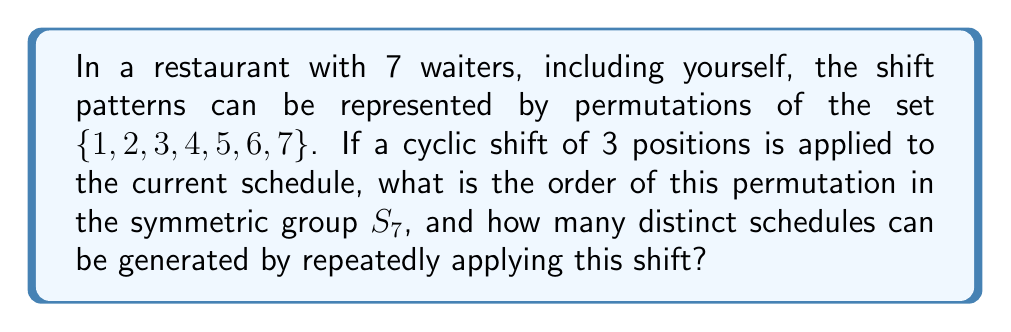What is the answer to this math problem? 1) The cyclic shift of 3 positions can be represented as the permutation:
   $\sigma = (1234567) \mapsto (4567123)$

2) This permutation can be written in cycle notation as:
   $\sigma = (1473625)$

3) The order of a permutation is the least common multiple (LCM) of the lengths of its disjoint cycles. Here, we have a single cycle of length 7.

4) Therefore, the order of $\sigma$ in $S_7$ is 7.

5) The number of distinct schedules generated by repeatedly applying this shift is equal to the order of the permutation.

6) Each application of the shift generates a new schedule until we return to the original schedule after 7 shifts.

7) Thus, the number of distinct schedules is also 7.
Answer: Order: 7; Distinct schedules: 7 